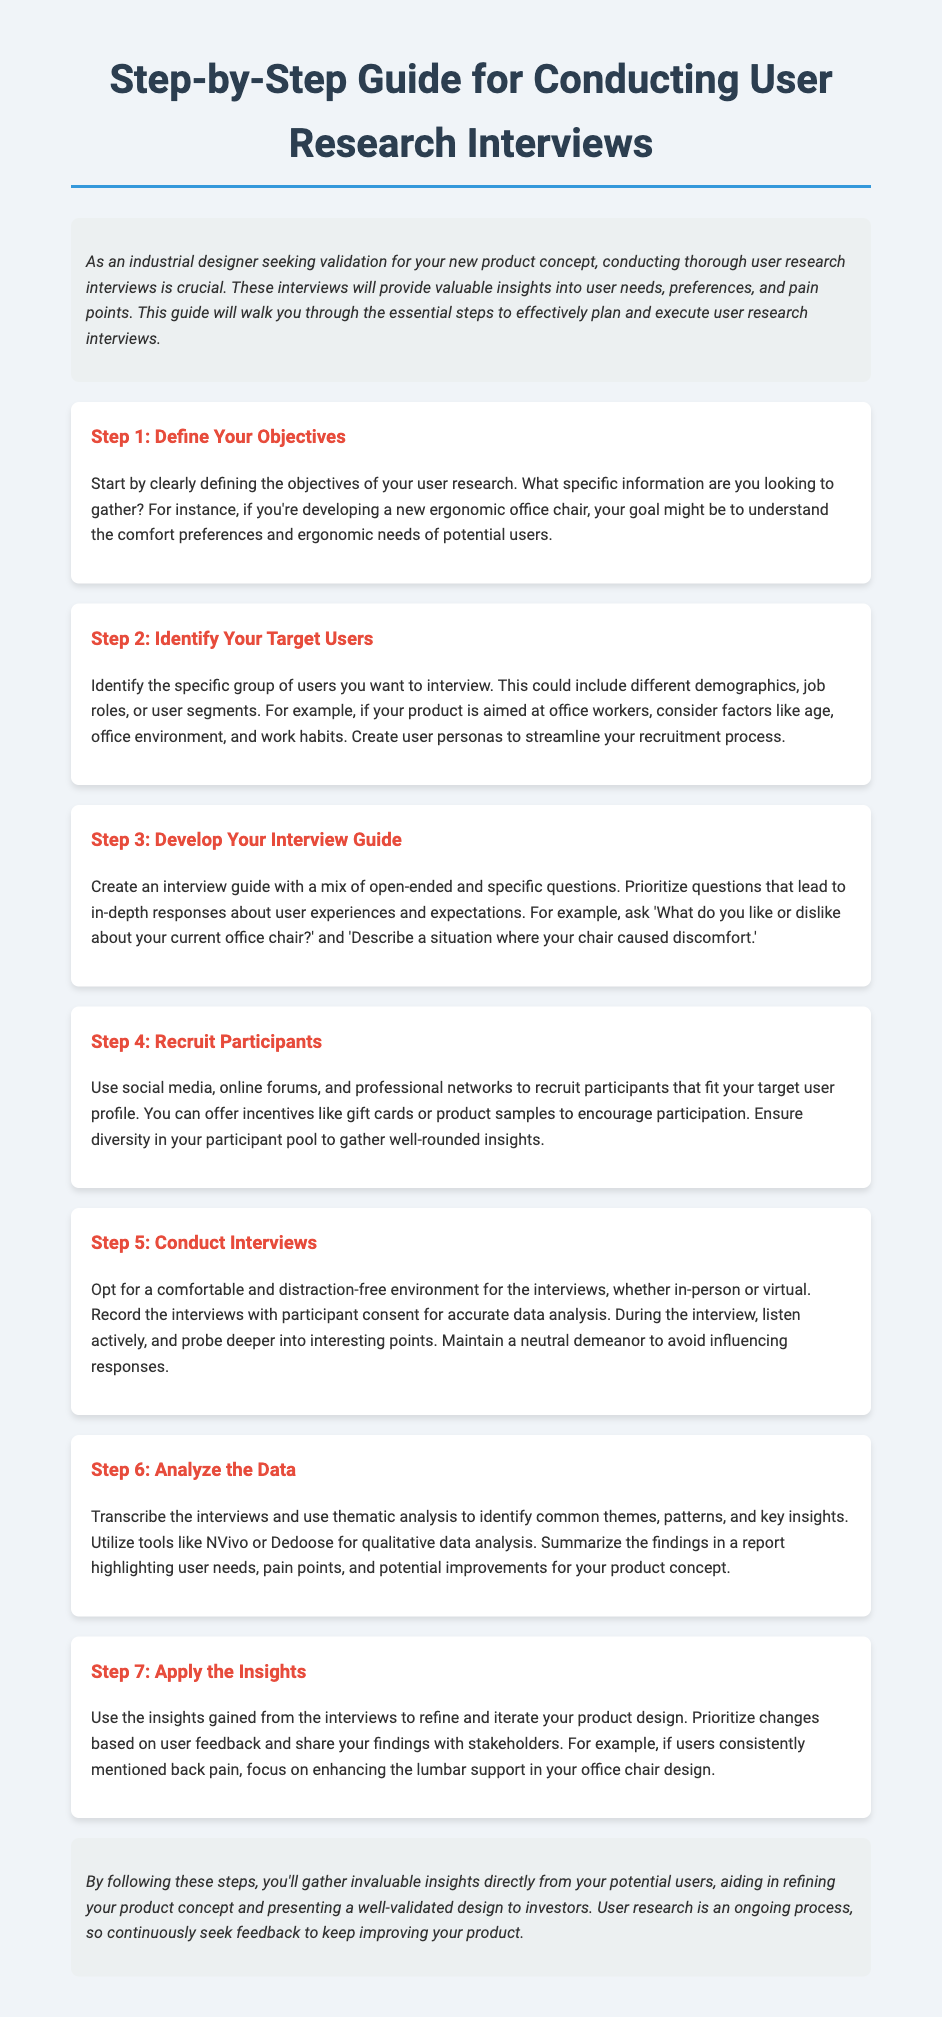What is the title of the guide? The title of the guide is presented in the document's header.
Answer: Step-by-Step Guide for Conducting User Research Interviews What is the first step in the user research process? The first step is outlined in the initial section of the guide.
Answer: Define Your Objectives What is one method suggested for recruiting participants? The document mentions methods for participant recruitment in Step 4.
Answer: Social media How many steps are there in the guide? The total number of steps is noted throughout the structured sections of the document.
Answer: Seven What should you ensure about your participant pool? The document highlights a key aspect of participant diversity.
Answer: Diversity What is a tool mentioned for analyzing qualitative data? The guide provides examples of tools for thematic analysis in Step 6.
Answer: NVivo What should be prioritized in your interview guide? The guide emphasizes the importance of certain types of questions during interviews.
Answer: Open-ended questions What is the main purpose of conducting user research interviews? The introduction of the guide outlines the primary objective of the research.
Answer: Gather insights 